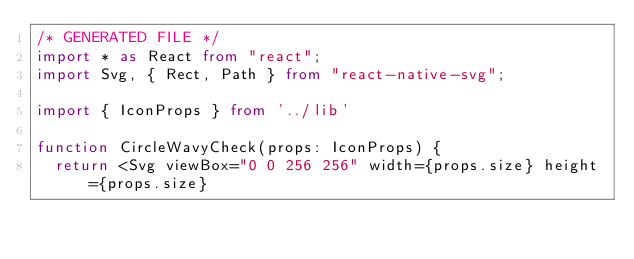Convert code to text. <code><loc_0><loc_0><loc_500><loc_500><_TypeScript_>/* GENERATED FILE */
import * as React from "react";
import Svg, { Rect, Path } from "react-native-svg";

import { IconProps } from '../lib'

function CircleWavyCheck(props: IconProps) {
  return <Svg viewBox="0 0 256 256" width={props.size} height={props.size}</code> 